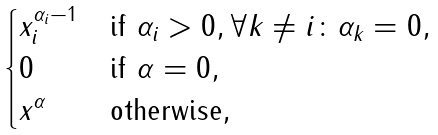<formula> <loc_0><loc_0><loc_500><loc_500>\begin{cases} x _ { i } ^ { \alpha _ { i } - 1 } & \text {if } \alpha _ { i } > 0 , \forall k \neq i \colon \alpha _ { k } = 0 , \\ 0 & \text {if } \alpha = 0 , \\ x ^ { \alpha } & \text {otherwise} , \\ \end{cases}</formula> 